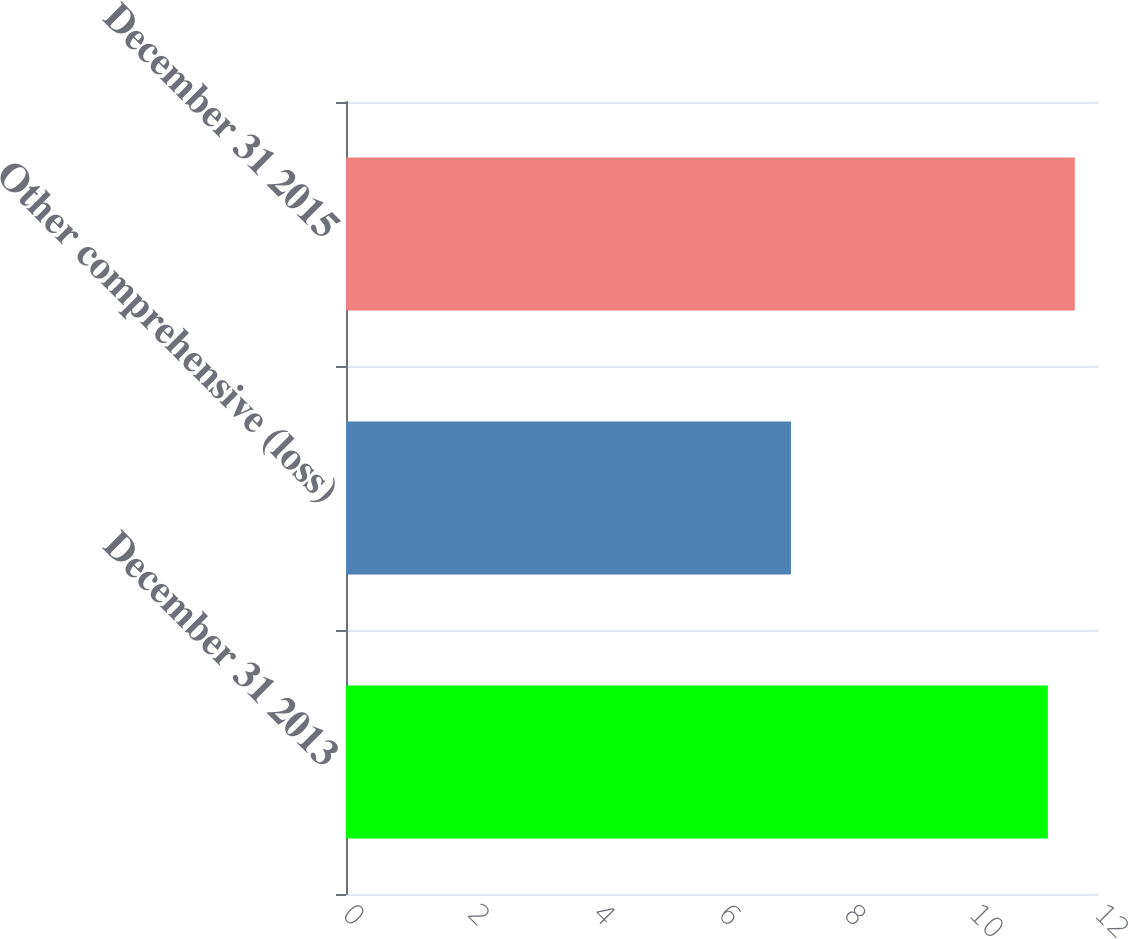Convert chart. <chart><loc_0><loc_0><loc_500><loc_500><bar_chart><fcel>December 31 2013<fcel>Other comprehensive (loss)<fcel>December 31 2015<nl><fcel>11.2<fcel>7.1<fcel>11.63<nl></chart> 